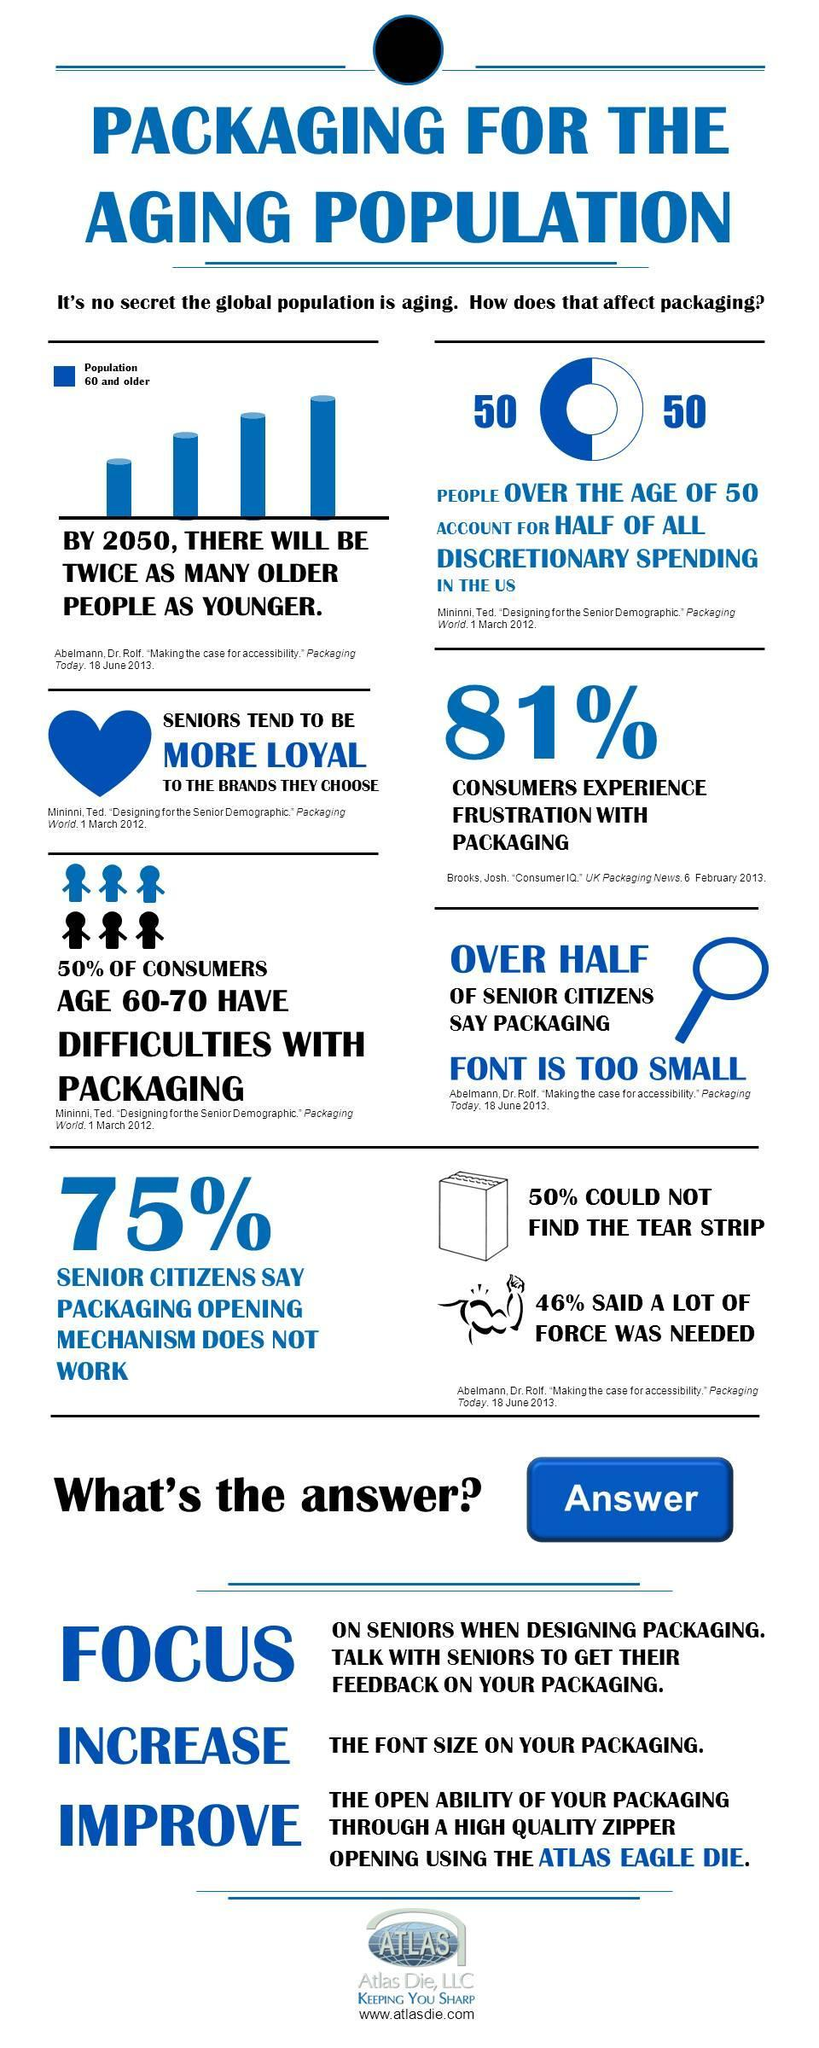People of which category are facing the most trouble with packaging?
Answer the question with a short phrase. Age 60-70 What percentage of senior people are facing trouble while opening the outer cover? 75% What percentage of customers are not happy with the outer covering? 81% 